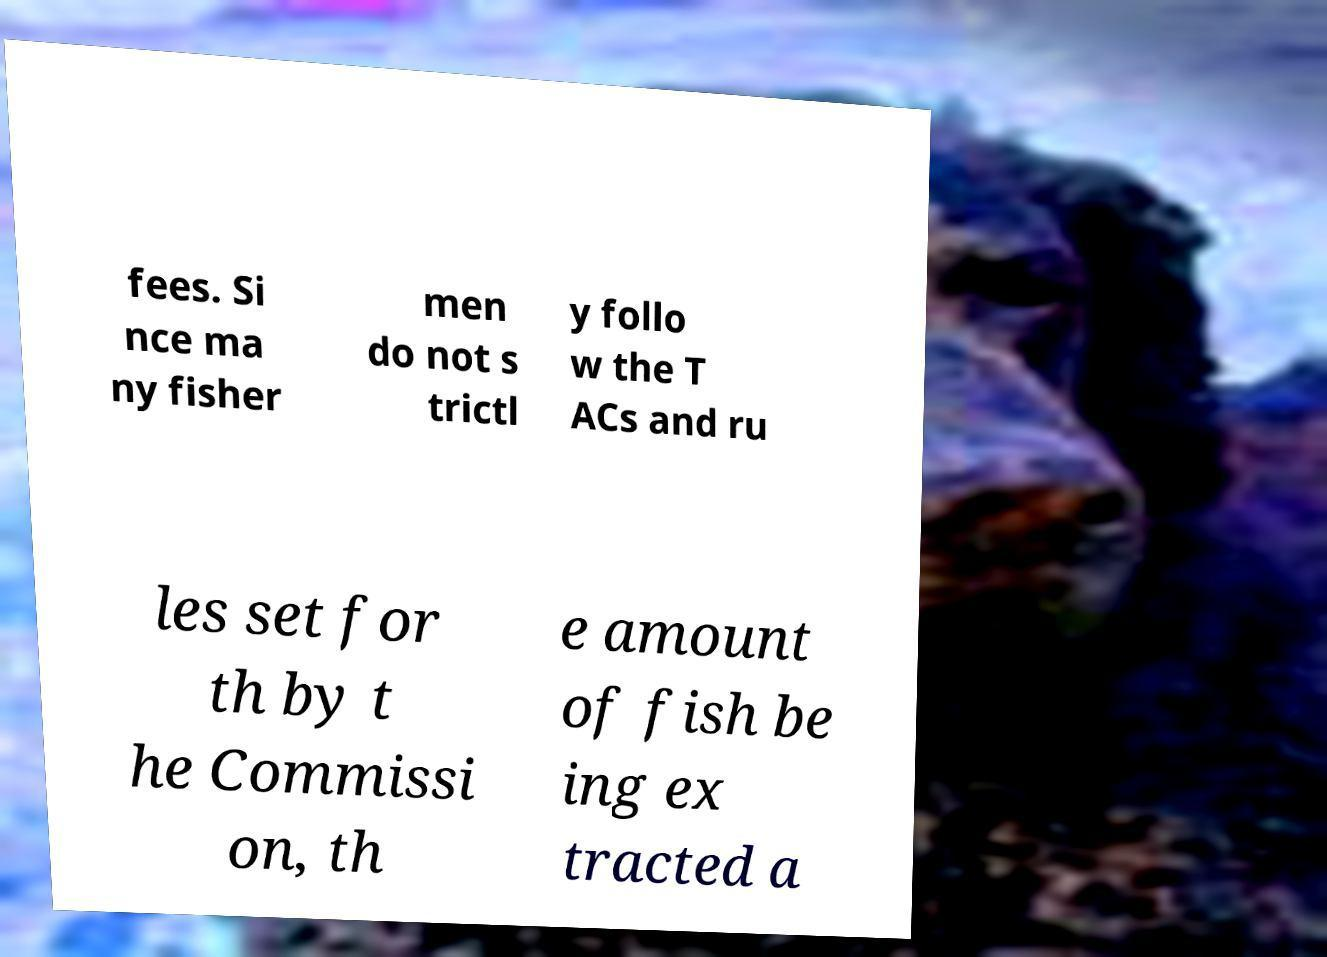There's text embedded in this image that I need extracted. Can you transcribe it verbatim? fees. Si nce ma ny fisher men do not s trictl y follo w the T ACs and ru les set for th by t he Commissi on, th e amount of fish be ing ex tracted a 